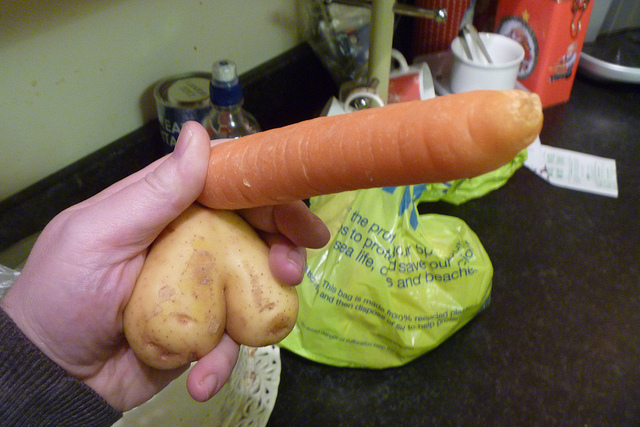Identify and read out the text in this image. and Sea 10 